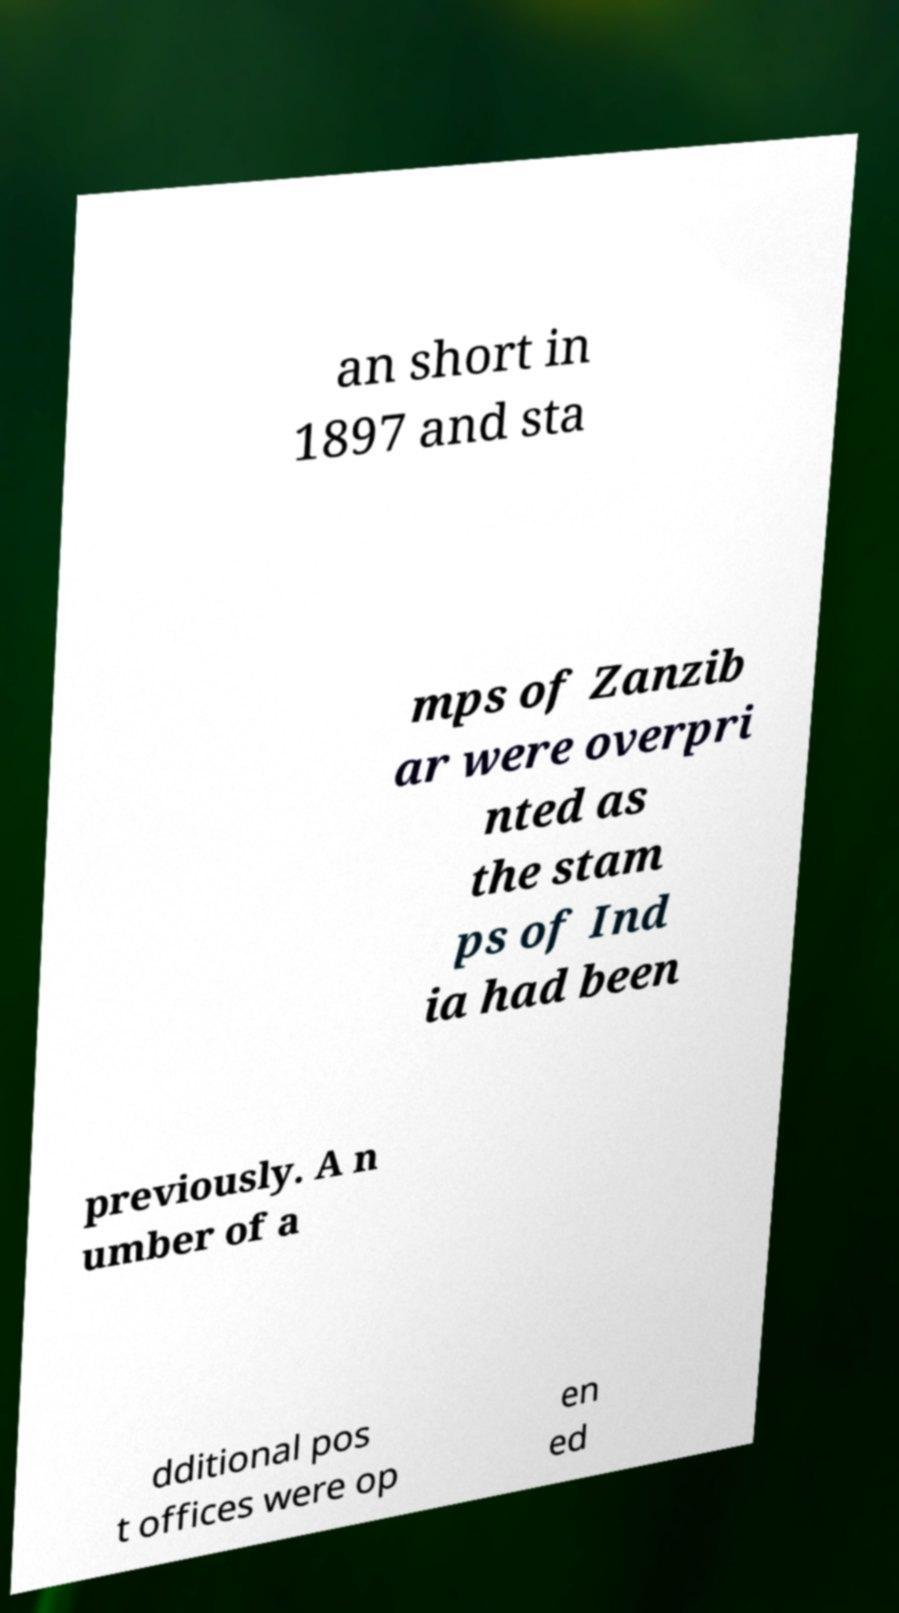I need the written content from this picture converted into text. Can you do that? an short in 1897 and sta mps of Zanzib ar were overpri nted as the stam ps of Ind ia had been previously. A n umber of a dditional pos t offices were op en ed 